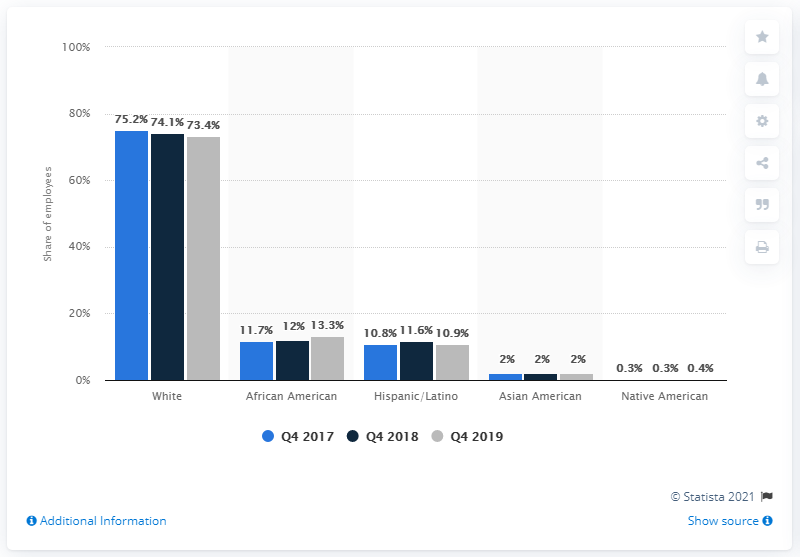Draw attention to some important aspects in this diagram. According to a recent study, 74.1% of TV newsroom employees are white. This represents a significant disparity in diversity within the television news industry. 